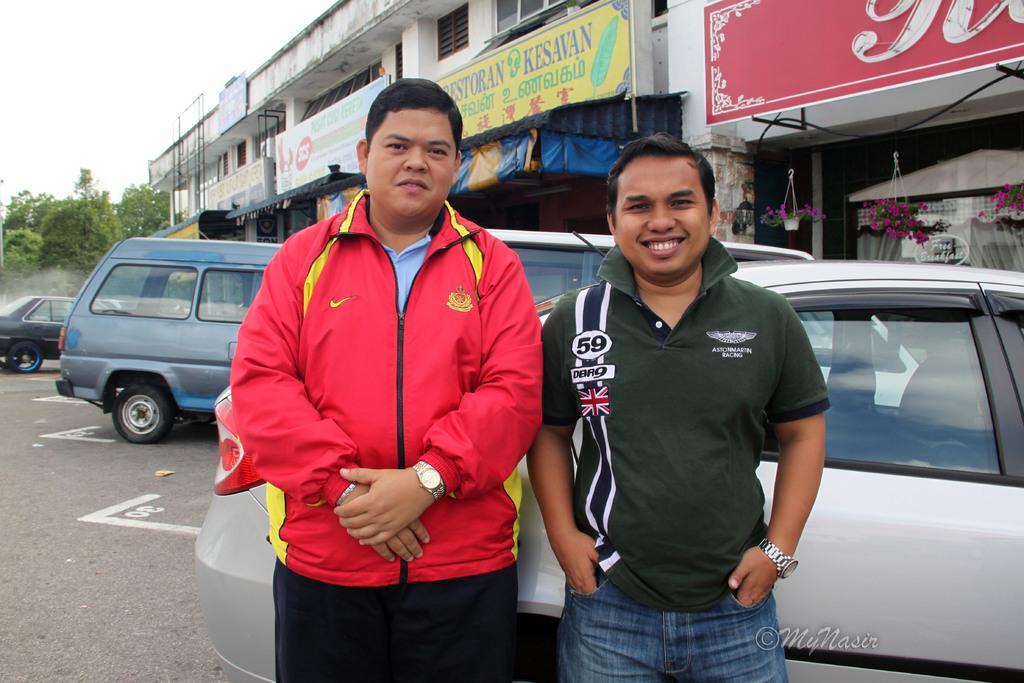Describe this image in one or two sentences. Here in this picture we can see two men standing on the road and we can see both of them are smiling and behind them we can see number of cars present on the road over there and we can also see buildings and hoardings and trees all over there. 